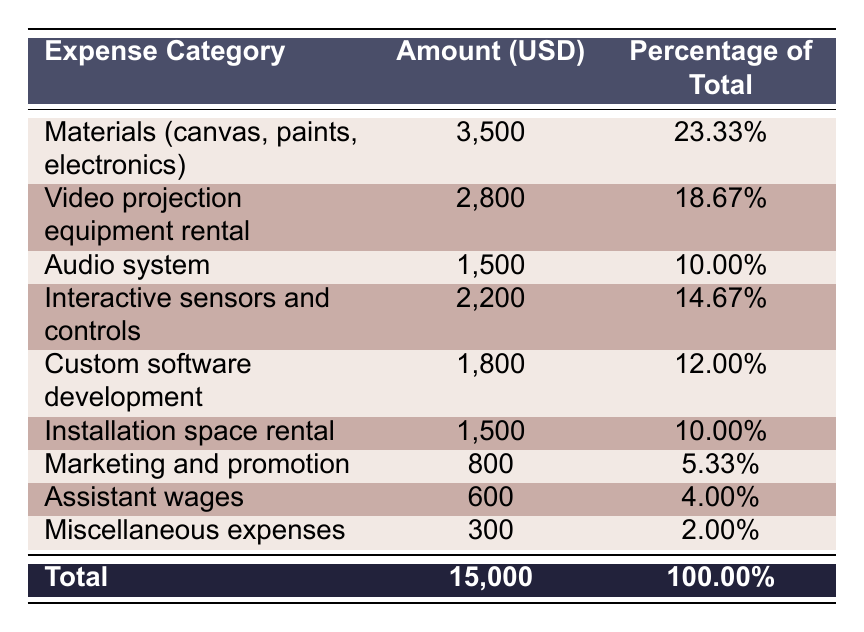What is the total budget for the multimedia installation? The total budget is listed at the bottom of the table, under the "Total" row. It shows an amount of 15,000 USD.
Answer: 15,000 USD What percentage of the total budget is allocated to materials? The "Materials (canvas, paints, electronics)" row provides a percentage figure of 23.33%, which indicates this portion of the budget.
Answer: 23.33% Is the cost of video projection equipment rental greater than that of the audio system? By comparing the amounts in their respective rows, video projection equipment rental costs 2,800 USD and the audio system costs 1,500 USD. Since 2,800 is greater than 1,500, the answer is yes.
Answer: Yes What are the total expenses for technology-related items, including video projection equipment, audio system, interactive sensors, and custom software? The relevant rows are: Video projection equipment (2,800), Audio system (1,500), Interactive sensors (2,200), and Custom software (1,800). Adding these amounts together gives: 2,800 + 1,500 + 2,200 + 1,800 = 8,300 USD.
Answer: 8,300 USD How much is spent on marketing and promotion compared to assistant wages? Marketing and promotion costs 800 USD, while assistant wages are 600 USD. The difference is calculated as: 800 - 600 = 200 USD. Hence, marketing and promotion exceeds assistant wages by 200 USD.
Answer: 200 USD What expense category has the lowest percentage of the total budget? Looking through the percentages in the table, "Miscellaneous expenses" has the lowest percentage at 2.00%.
Answer: Miscellaneous expenses What is the combined percentage of the budget allocated for installation space rental and audio system? The percentage for Installation space rental is 10.00% and for the Audio system is 10.00%. Adding these together gives: 10.00 + 10.00 = 20.00%.
Answer: 20.00% Is the total amount spent on materials and interactive sensors more than 6,000 USD? The amounts for materials (3,500) and interactive sensors (2,200) add up to 5,700 USD (3,500 + 2,200). Since 5,700 is less than 6,000, the answer is no.
Answer: No What is the amount spent on all expenses categorized as "other"? The "other" related expenses include Marketing and promotion (800), Assistant wages (600), and Miscellaneous expenses (300). Adding these gives: 800 + 600 + 300 = 1,700 USD.
Answer: 1,700 USD 